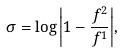Convert formula to latex. <formula><loc_0><loc_0><loc_500><loc_500>\sigma = \log { \left | 1 - \frac { f ^ { 2 } } { f ^ { 1 } } \right | } ,</formula> 